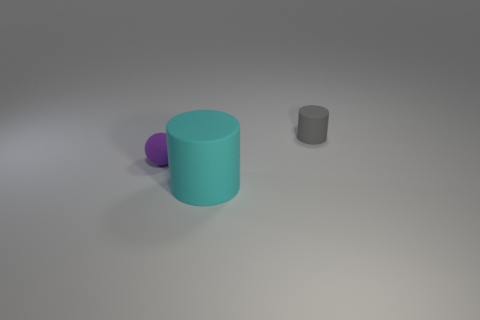The small purple thing is what shape?
Your response must be concise. Sphere. How many blue things are either cylinders or large objects?
Provide a succinct answer. 0. How many other things are there of the same material as the large object?
Give a very brief answer. 2. Do the matte thing that is right of the big cyan cylinder and the big cyan matte object have the same shape?
Ensure brevity in your answer.  Yes. Are any large rubber objects visible?
Offer a terse response. Yes. Is there any other thing that has the same shape as the small purple object?
Ensure brevity in your answer.  No. Is the number of rubber cylinders right of the cyan cylinder greater than the number of big yellow rubber cylinders?
Your answer should be compact. Yes. There is a tiny purple rubber thing; are there any matte things in front of it?
Offer a very short reply. Yes. Does the cyan matte thing have the same size as the purple thing?
Offer a terse response. No. What is the size of the other rubber thing that is the same shape as the big cyan thing?
Make the answer very short. Small. 